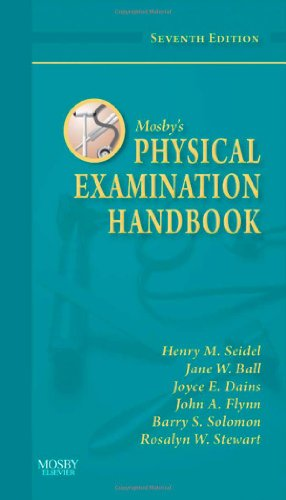Is this book related to Medical Books? Yes, this book is intimately related to Medical Books as it serves as a practical guide for healthcare professionals to conduct thorough physical examinations. 